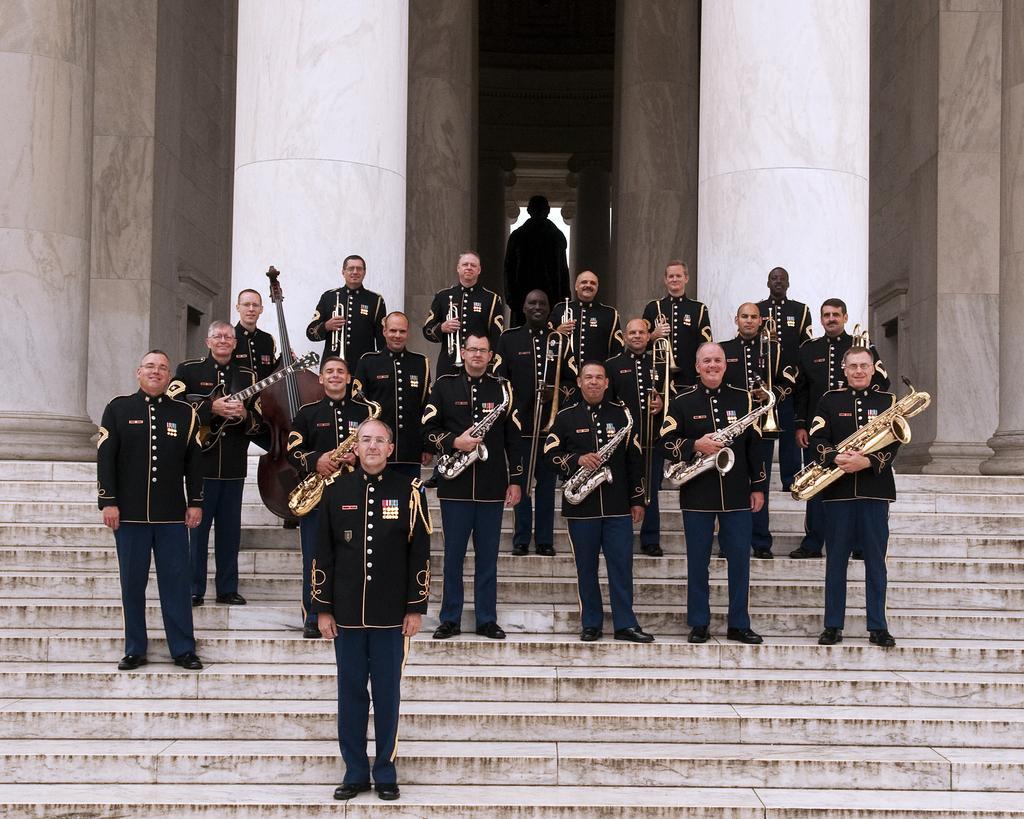In one or two sentences, can you explain what this image depicts? In this image, we can see people wearing uniforms and standing and some are holding musical instruments. In the background, there are pillars and there is a wall and at the bottom, there are stairs. 